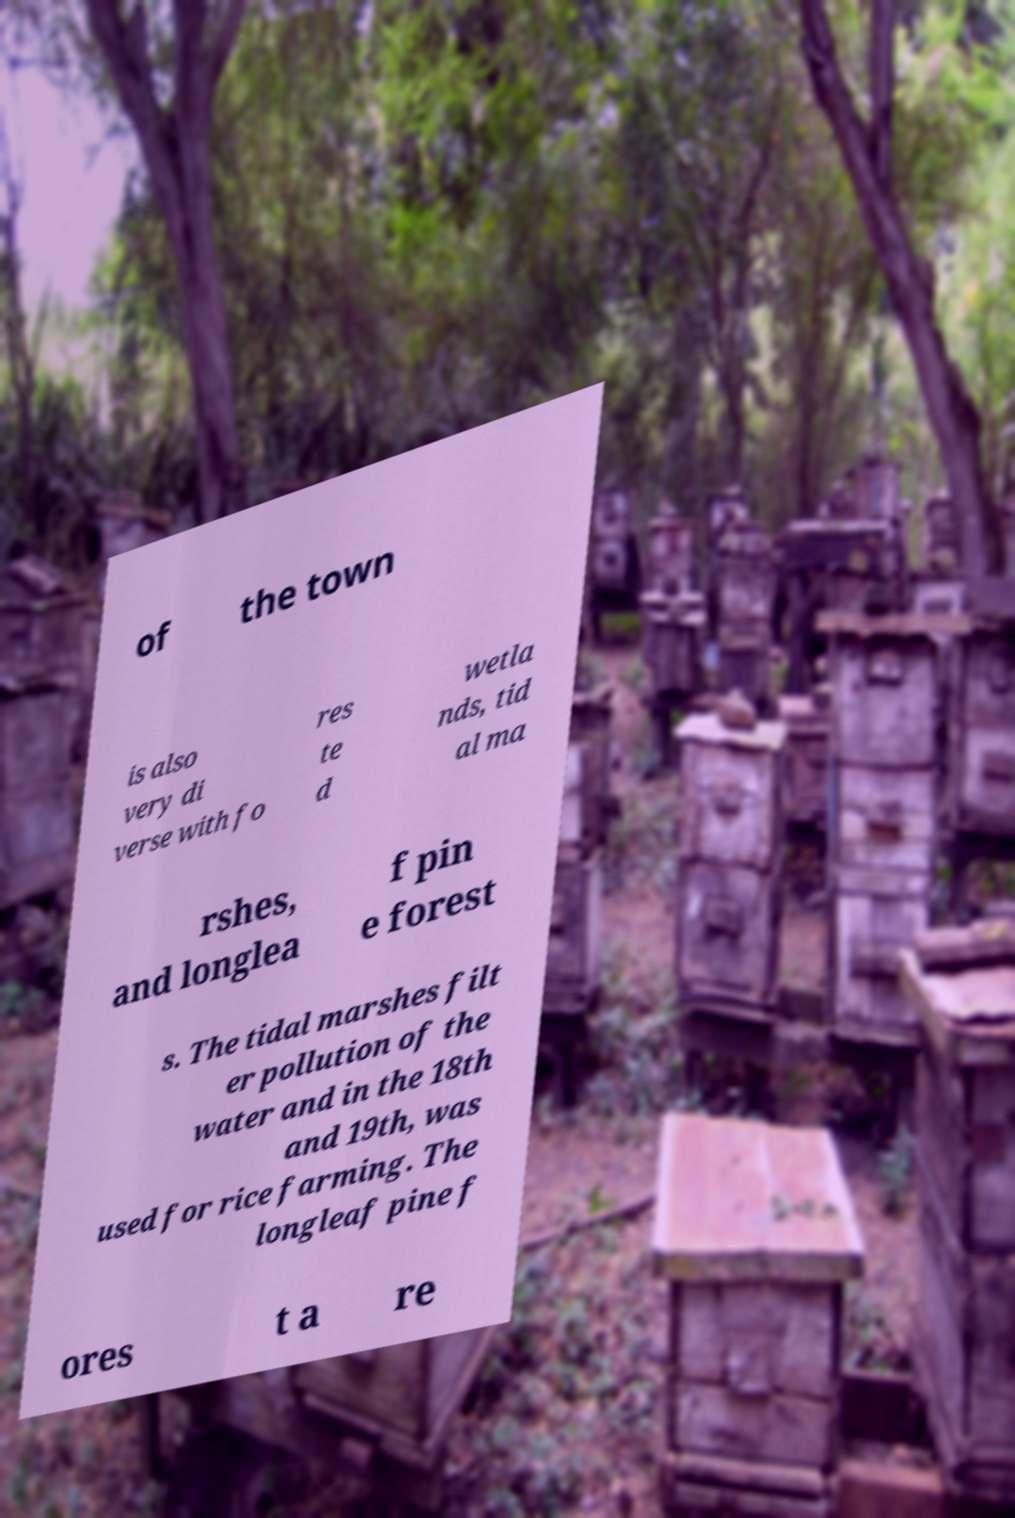For documentation purposes, I need the text within this image transcribed. Could you provide that? of the town is also very di verse with fo res te d wetla nds, tid al ma rshes, and longlea f pin e forest s. The tidal marshes filt er pollution of the water and in the 18th and 19th, was used for rice farming. The longleaf pine f ores t a re 